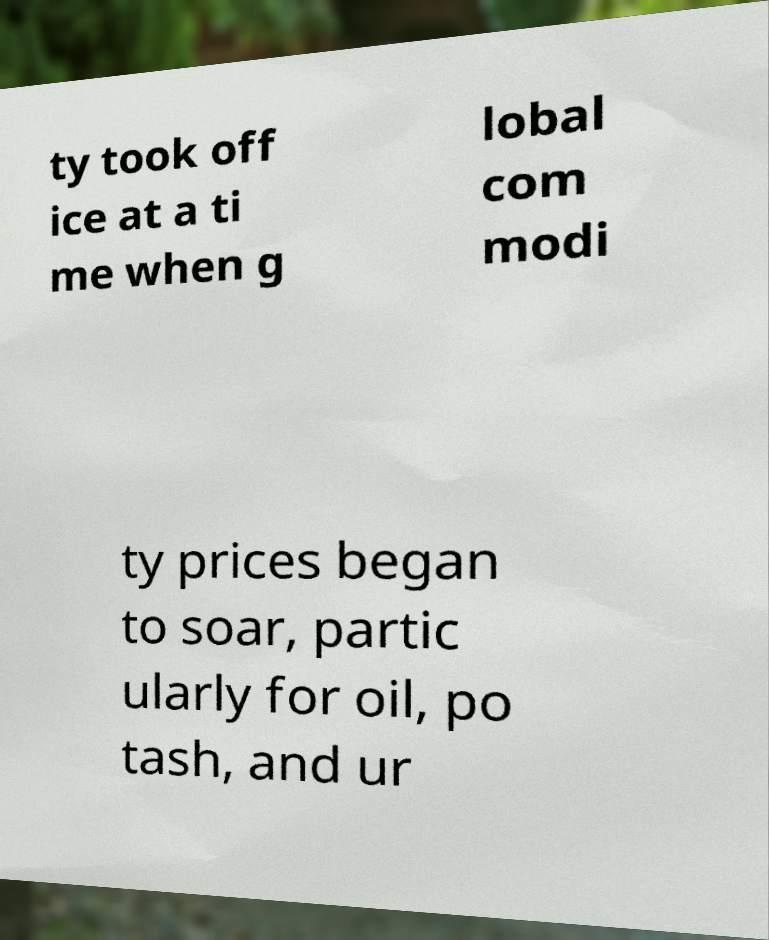What messages or text are displayed in this image? I need them in a readable, typed format. ty took off ice at a ti me when g lobal com modi ty prices began to soar, partic ularly for oil, po tash, and ur 